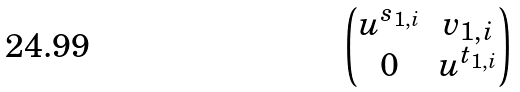<formula> <loc_0><loc_0><loc_500><loc_500>\begin{pmatrix} u ^ { s _ { 1 , i } } & v _ { 1 , i } \\ 0 & u ^ { t _ { 1 , i } } \end{pmatrix}</formula> 